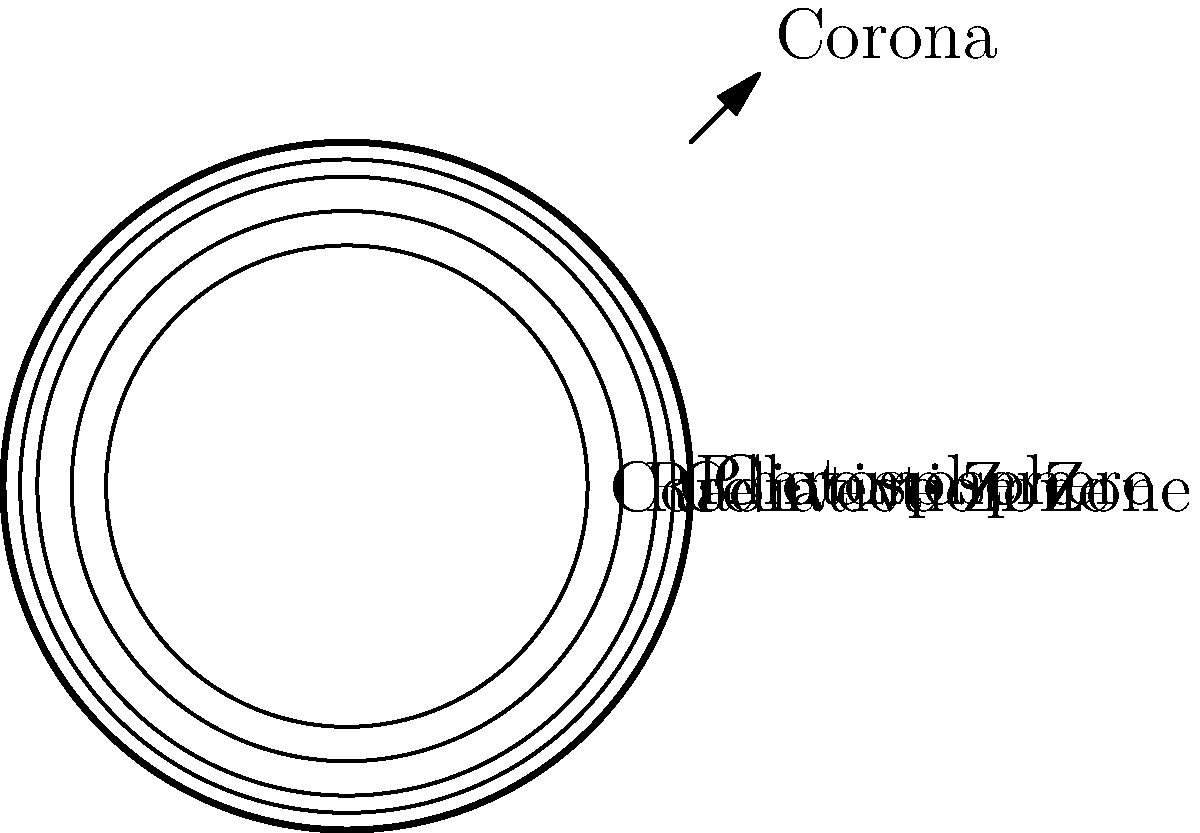As a tennis coach prioritizing athlete safety, understanding the Sun's structure is crucial for outdoor training. Which layer of the Sun is responsible for the visible light we see and is most relevant for assessing UV exposure risks during practice? To answer this question, let's examine the layers of the Sun from the inside out:

1. Core: The innermost layer where nuclear fusion occurs.
2. Radiative Zone: Energy is transferred outward through radiation.
3. Convection Zone: Energy moves through convection currents.
4. Photosphere: This is the visible "surface" of the Sun.
5. Chromosphere: A thin layer above the photosphere.
6. Corona: The outermost layer of the Sun's atmosphere.

The photosphere is the layer that emits the visible light we see from Earth. It's also the primary source of UV radiation that reaches Earth's surface. As a tennis coach concerned about athlete safety, this layer is most relevant for assessing UV exposure risks during outdoor practice sessions.

The photosphere has a temperature of about 5,800 Kelvin and is the layer where sunspots are observed. It's relatively thin compared to other layers, being only about 500 km thick.

Understanding the role of the photosphere helps in making informed decisions about scheduling practices, recommending appropriate sun protection measures, and educating athletes about the importance of UV safety in tennis.
Answer: Photosphere 